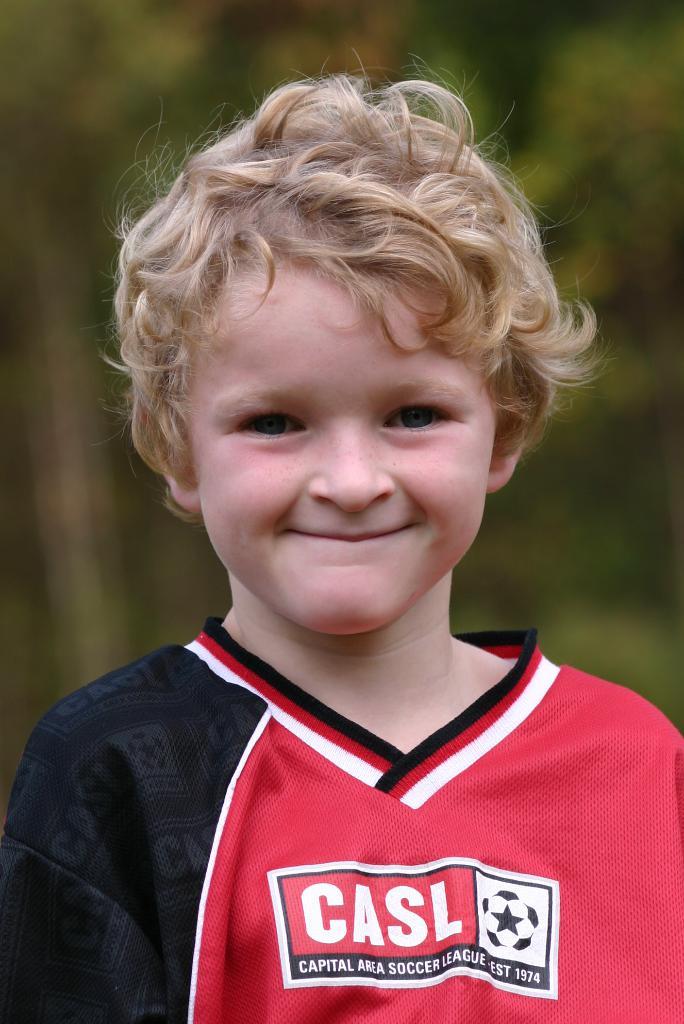What soccer league is shown on the child's chest?
Your answer should be compact. Casl. That gameis on the shirt?
Give a very brief answer. Soccer. 